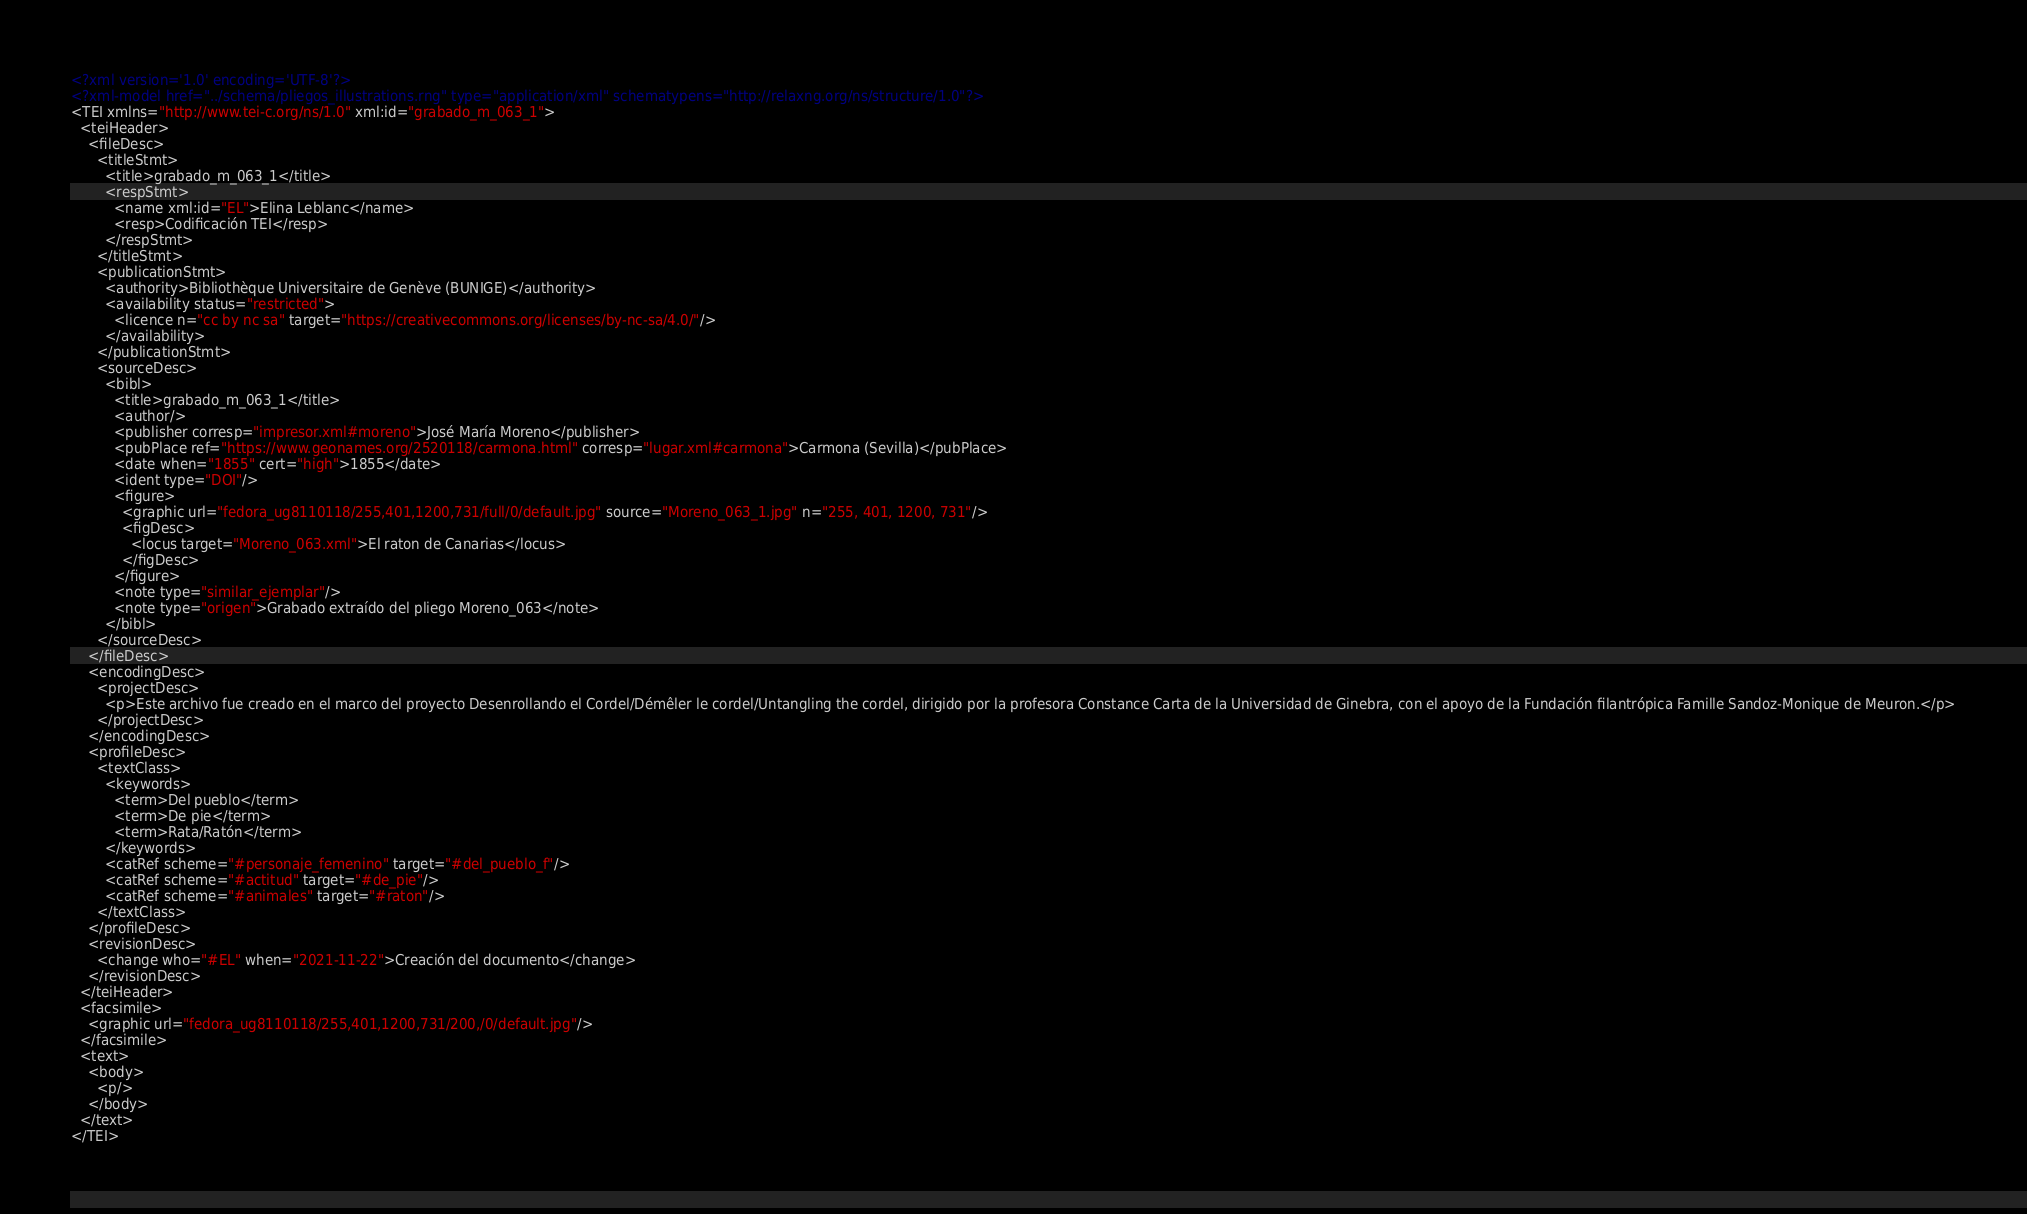Convert code to text. <code><loc_0><loc_0><loc_500><loc_500><_XML_><?xml version='1.0' encoding='UTF-8'?>
<?xml-model href="../schema/pliegos_illustrations.rng" type="application/xml" schematypens="http://relaxng.org/ns/structure/1.0"?>
<TEI xmlns="http://www.tei-c.org/ns/1.0" xml:id="grabado_m_063_1">
  <teiHeader>
    <fileDesc>
      <titleStmt>
        <title>grabado_m_063_1</title>
        <respStmt>
          <name xml:id="EL">Elina Leblanc</name>
          <resp>Codificación TEI</resp>
        </respStmt>
      </titleStmt>
      <publicationStmt>
        <authority>Bibliothèque Universitaire de Genève (BUNIGE)</authority>
        <availability status="restricted">
          <licence n="cc by nc sa" target="https://creativecommons.org/licenses/by-nc-sa/4.0/"/>
        </availability>
      </publicationStmt>
      <sourceDesc>
        <bibl>
          <title>grabado_m_063_1</title>
          <author/>
          <publisher corresp="impresor.xml#moreno">José María Moreno</publisher>
          <pubPlace ref="https://www.geonames.org/2520118/carmona.html" corresp="lugar.xml#carmona">Carmona (Sevilla)</pubPlace>
          <date when="1855" cert="high">1855</date>
          <ident type="DOI"/>
          <figure>
            <graphic url="fedora_ug8110118/255,401,1200,731/full/0/default.jpg" source="Moreno_063_1.jpg" n="255, 401, 1200, 731"/>
            <figDesc>
              <locus target="Moreno_063.xml">El raton de Canarias</locus>
            </figDesc>
          </figure>
          <note type="similar_ejemplar"/>
          <note type="origen">Grabado extraído del pliego Moreno_063</note>
        </bibl>
      </sourceDesc>
    </fileDesc>
    <encodingDesc>
      <projectDesc>
        <p>Este archivo fue creado en el marco del proyecto Desenrollando el Cordel/Démêler le cordel/Untangling the cordel, dirigido por la profesora Constance Carta de la Universidad de Ginebra, con el apoyo de la Fundación filantrópica Famille Sandoz-Monique de Meuron.</p>
      </projectDesc>
    </encodingDesc>
    <profileDesc>
      <textClass>
        <keywords>
          <term>Del pueblo</term>
          <term>De pie</term>
          <term>Rata/Ratón</term>
        </keywords>
        <catRef scheme="#personaje_femenino" target="#del_pueblo_f"/>
        <catRef scheme="#actitud" target="#de_pie"/>
        <catRef scheme="#animales" target="#raton"/>
      </textClass>
    </profileDesc>
    <revisionDesc>
      <change who="#EL" when="2021-11-22">Creación del documento</change>
    </revisionDesc>
  </teiHeader>
  <facsimile>
    <graphic url="fedora_ug8110118/255,401,1200,731/200,/0/default.jpg"/>
  </facsimile>
  <text>
    <body>
      <p/>
    </body>
  </text>
</TEI></code> 